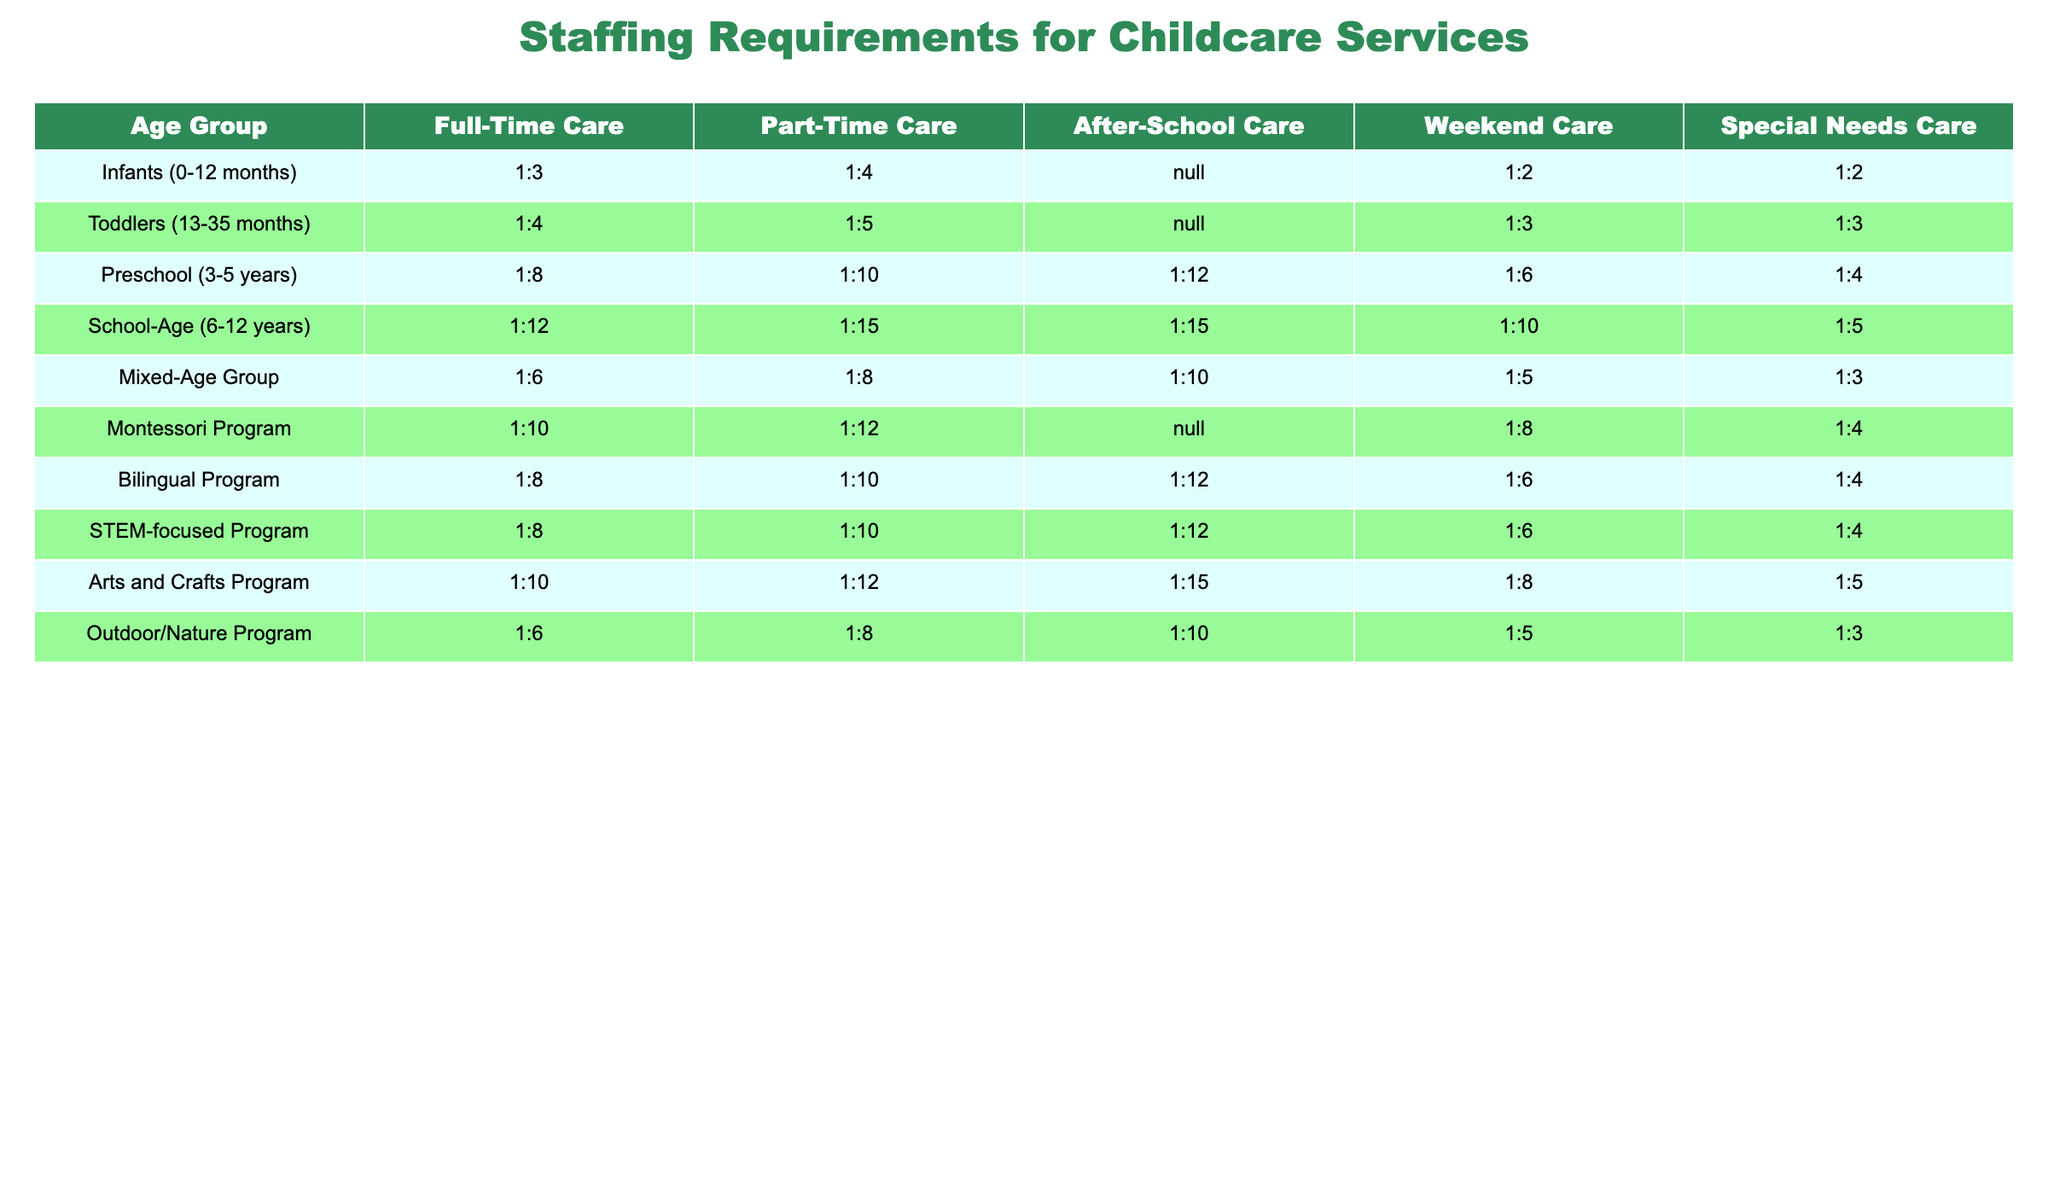What is the ratio of caregivers to infants in full-time care? The staffing requirement for infants in full-time care is 1:3, meaning one caregiver is needed for every three infants.
Answer: 1:3 How many more children can be cared for in part-time care for toddlers compared to full-time care? For toddlers, full-time care has a ratio of 1:4 and part-time care has a ratio of 1:5. This means that for every full-time caregiver, four toddlers can be cared for, while five can be cared for per part-time caregiver. Thus, one more child can be cared for in part-time care than in full-time care.
Answer: 1 more child Is the caregiver-to-child ratio for weekend care lower for school-age children than for infants? For school-age children, the ratio in weekend care is 1:10, and for infants, it is 1:2. Since a lower ratio indicates fewer children per caregiver, the ratio for infants is indeed lower than that for school-age children.
Answer: Yes What is the combined caregiver-to-child ratio for infants and toddlers in special needs care? For infants, the ratio is 1:2 and for toddlers it is also 1:3. The average caregiver-to-child ratio can be found by considering the weights (2 + 3) and respective caregivers used (1 for each). Combined, the overall ratios in this context are not directly averaged but considered separately as the ratios apply to different populations.
Answer: Not applicable Which care offering has the highest required caregiver-to-child ratio for preschool children? For preschool children, the ratios in various offerings are: full-time care 1:8, part-time care 1:10, after-school care 1:12, weekend care 1:6, and special needs care 1:4. The highest caregiver-to-child ratio for preschool children is in after-school care, at 1:12.
Answer: 1:12 How many total different caregiver-to-child ratios are listed for toddler care services? The table lists four different care service offerings for toddlers: full-time, part-time, weekend, and special needs. Thus, there are a total of four unique ratios for toddlers.
Answer: 4 What is the most lenient caregiver-to-child ratio for after-school care across all age groups? Reviewing the after-school care ratios, infants and toddlers cannot have after-school offerings, while preschool has 1:12, school-age has 1:15, and mixed-age have 1:10. The most lenient ratio (the highest numbers, meaning the lowest oversight) is 1:15 for school-age children.
Answer: 1:15 For the Montessori Program, what is the ratio of caregivers to children for part-time care? In the Montessori Program for part-time care, the required ratio is 1:12, indicating one caregiver for every twelve children.
Answer: 1:12 How does the caregiver-to-child ratio for School-Age in part-time compare to the ratio for Infants in full-time care? The ratio for School-Age in part-time care is 1:15 and for Infants in full-time care is 1:3. The difference shows that School-Age requires fewer caregivers per child than Infants, indicating more children per caregiver in part-time care for school-age children.
Answer: School-Age is more lenient (1:15) than Infants (1:3) In which care service offering do mixed-age groups have the least number of children per caregiver? For mixed-age groups, the respective ratios are: full-time 1:6, part-time 1:8, after-school 1:10, weekend 1:5, special needs 1:3. The least number of children per caregiver (best oversight) is found in weekend care with a ratio of 1:5.
Answer: Weekend Care (1:5) 